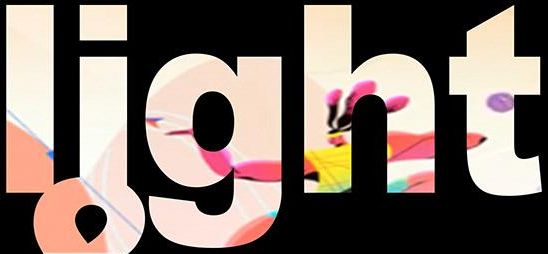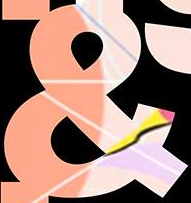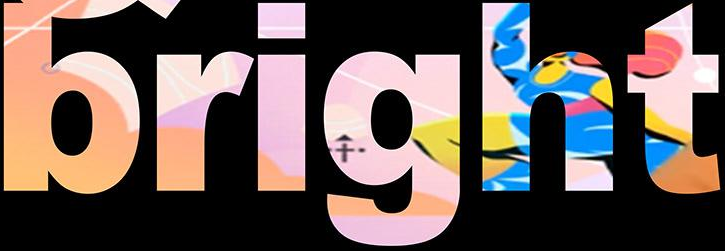What text appears in these images from left to right, separated by a semicolon? light; &; bright 